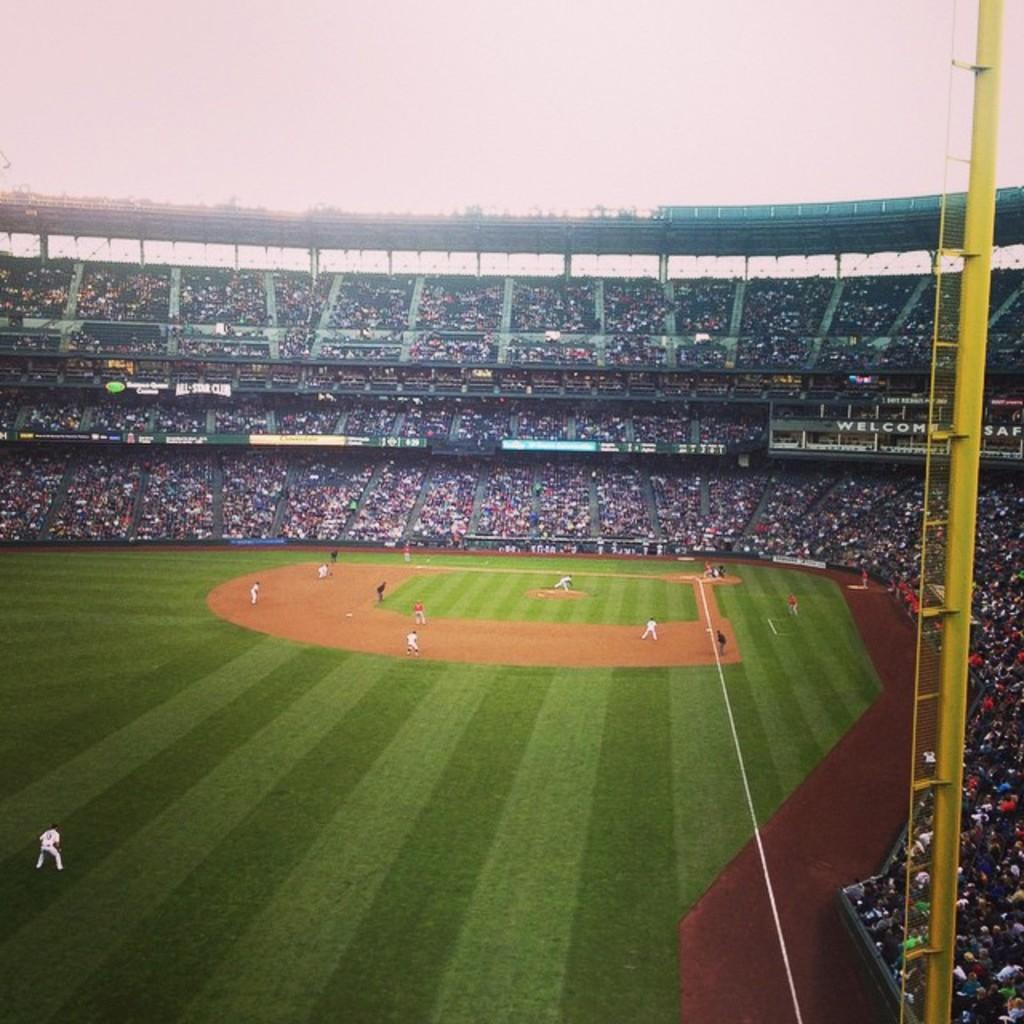What can be seen in the image? There are people standing in the image. Where are the people standing? The people are standing on the ground. What else can be observed in the background of the image? There is an audience in the background of the image. What type of tree is being raked by the people in the image? There is no tree or rake present in the image; it only shows people standing and an audience in the background. 